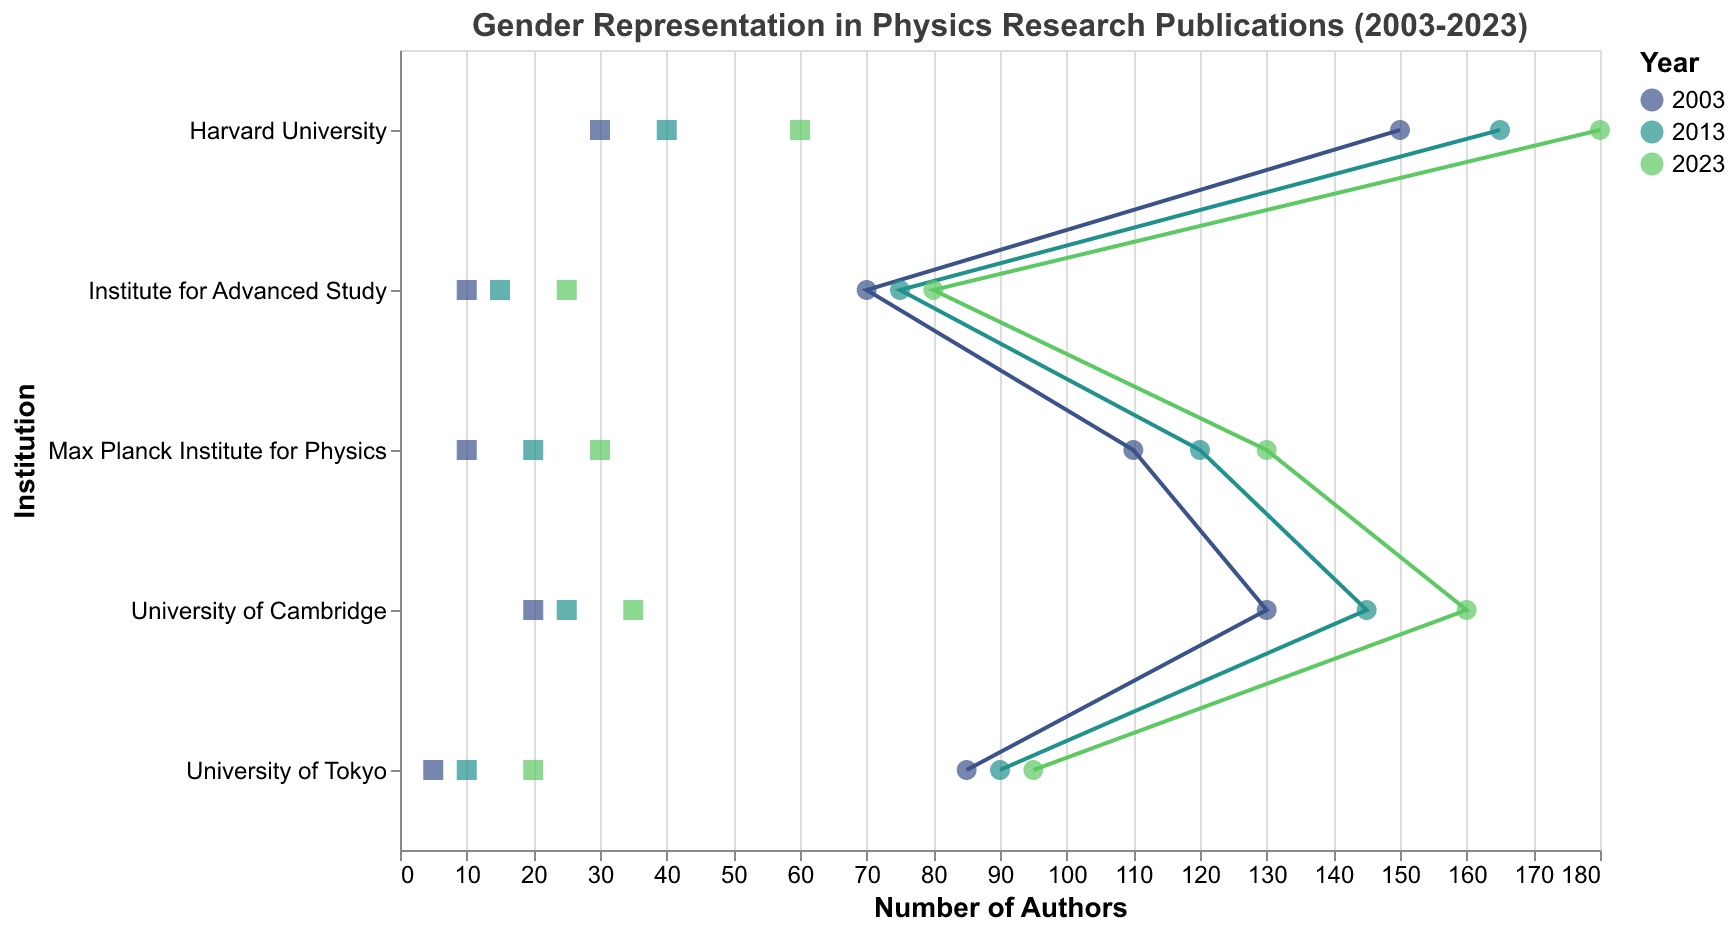Which institution had the highest number of male authors in 2003? The figure shows the number of male authors for each institution by year. For 2003, Harvard University has the highest value.
Answer: Harvard University Which year shows the largest increase in the number of female authors at the Max Planck Institute for Physics? By examining the changes in the number of female authors across years, we see that the increase from 2013 to 2023 is larger than from 2003 to 2013 (20 - 10 = 10 vs. 30 - 20 = 10, 10 is larger). This can be confirmed visually by noting the larger distance between the points in the later years.
Answer: 2013 to 2023 What is the total number of female authors at the University of Tokyo across all years shown? Adding the number of female authors for the University of Tokyo for the years 2003, 2013, and 2023: 5 + 10 + 20.
Answer: 35 In which year did Harvard University have a significantly higher representation of female authors compared to male authors? Looking at Harvard University's data points, we notice that while the number of female authors increases, it is also increasing for the male authors. However, visually, the gap reduction in 2023 is the most significant indicating higher female author representation compared to previous years.
Answer: 2023 Which institution showed the smallest number of male authors in 2003 and how many were there? Examining the number of male authors for all institutions in 2003, the University of Tokyo had the smallest number.
Answer: University of Tokyo with 85 male authors How did the number of female authors change at the Institute for Advanced Study from 2003 to 2023? Subtract the number of female authors in 2003 from the number in 2023: 25 - 10.
Answer: Increased by 15 Which institution and year combination had the highest number of total authors (both male and female)? To find the highest total number of authors, we sum male and female authors for each institution and year. Harvard University in 2023 has the highest total (180 + 60 = 240).
Answer: Harvard University in 2023 What trend can be observed in the number of female authors at University of Cambridge from 2003 to 2023? Observing the data points for University of Cambridge, we see an increasing trend in the number of female authors from 20 in 2003, to 25 in 2013, and 35 in 2023.
Answer: Increasing trend For which institution did female authors make up exactly 25% of the total authors in 2023? Female authors divided by the total number of authors for each institution in 2023 should be 0.25. For University of Tokyo, it’s 20/(95+20)=0.25.
Answer: University of Tokyo Which country had the highest total number of male authors in 2023? Summing up the number of male authors for all institutions in each country: USA (180+80) = 260, UK = 160, Germany = 130, Japan = 95.
Answer: USA 